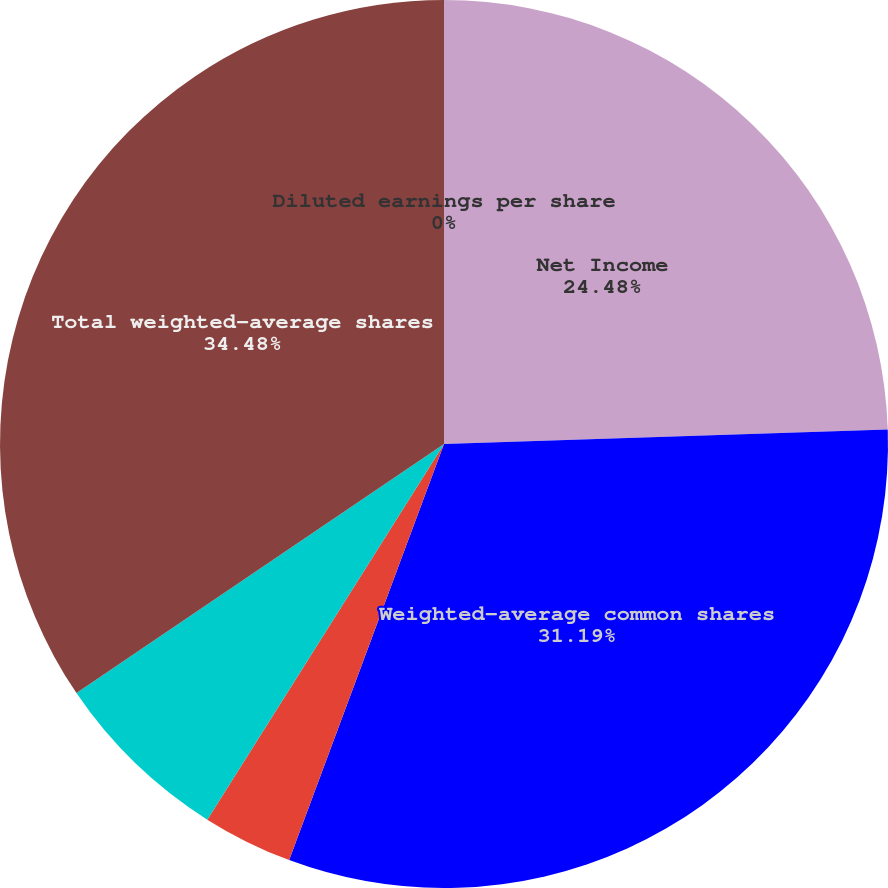<chart> <loc_0><loc_0><loc_500><loc_500><pie_chart><fcel>Net Income<fcel>Weighted-average common shares<fcel>Basic earnings per share<fcel>Effect of dilutive options<fcel>Total weighted-average shares<fcel>Diluted earnings per share<nl><fcel>24.48%<fcel>31.19%<fcel>3.28%<fcel>6.57%<fcel>34.48%<fcel>0.0%<nl></chart> 